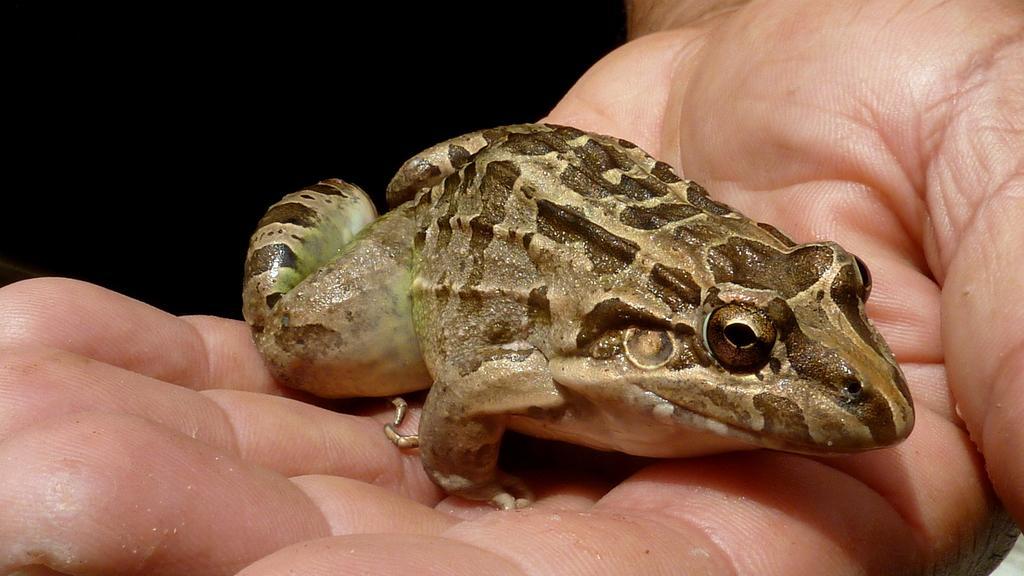Please provide a concise description of this image. In this image I see the hand on which there is a frog which is of cream, brown and green in color and it is dark in the background. 